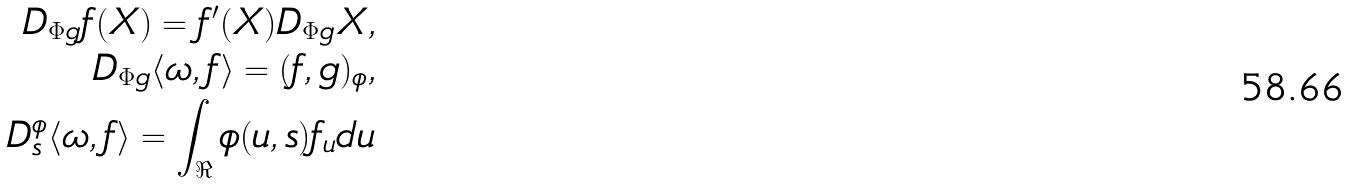Convert formula to latex. <formula><loc_0><loc_0><loc_500><loc_500>D _ { \Phi g } f ( X ) = f ^ { \prime } ( X ) D _ { \Phi g } X , \\ D _ { \Phi g } \langle \omega , f \rangle = ( f , g ) _ { \phi } , \\ D ^ { \phi } _ { s } \langle \omega , f \rangle = \int _ { \Re } \phi ( u , s ) f _ { u } d u</formula> 